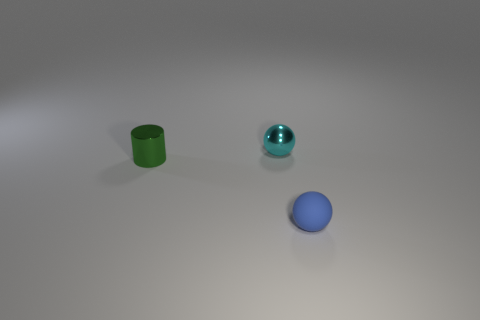Subtract all purple spheres. Subtract all red cylinders. How many spheres are left? 2 Add 3 matte balls. How many objects exist? 6 Subtract all cylinders. How many objects are left? 2 Subtract all tiny green rubber cylinders. Subtract all tiny spheres. How many objects are left? 1 Add 3 small metal balls. How many small metal balls are left? 4 Add 2 tiny metal cylinders. How many tiny metal cylinders exist? 3 Subtract 1 cyan balls. How many objects are left? 2 